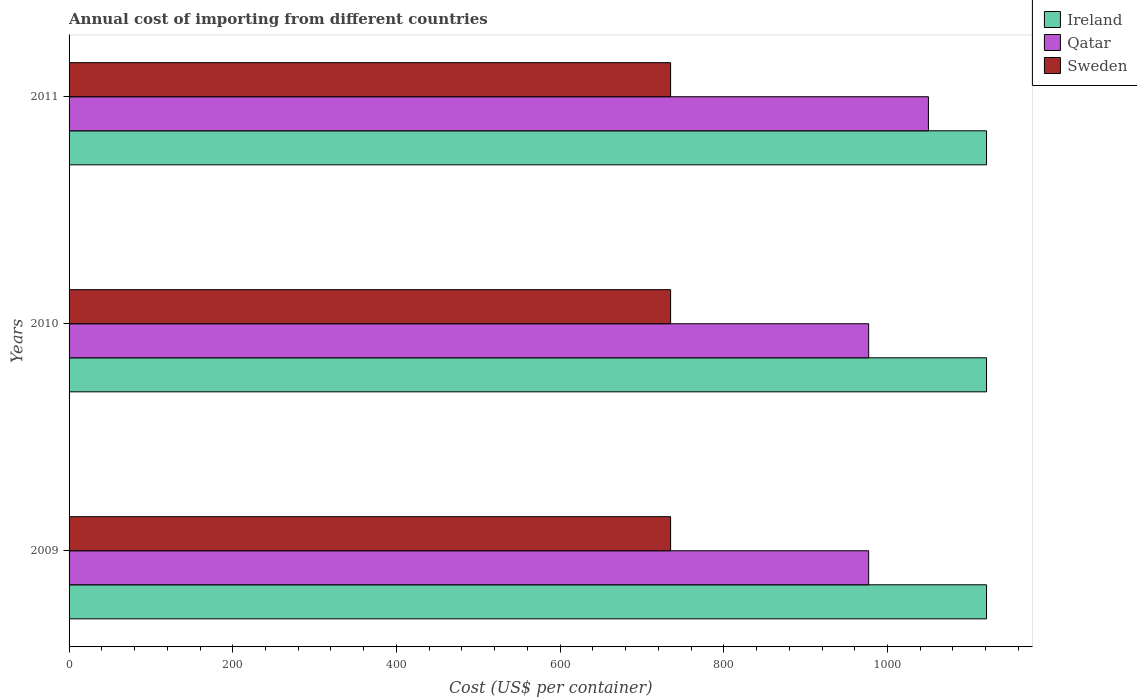What is the total annual cost of importing in Qatar in 2009?
Make the answer very short. 977. Across all years, what is the maximum total annual cost of importing in Sweden?
Make the answer very short. 735. Across all years, what is the minimum total annual cost of importing in Qatar?
Your answer should be very brief. 977. In which year was the total annual cost of importing in Sweden maximum?
Give a very brief answer. 2009. What is the total total annual cost of importing in Sweden in the graph?
Give a very brief answer. 2205. What is the difference between the total annual cost of importing in Ireland in 2009 and the total annual cost of importing in Sweden in 2011?
Keep it short and to the point. 386. What is the average total annual cost of importing in Sweden per year?
Provide a short and direct response. 735. In the year 2010, what is the difference between the total annual cost of importing in Qatar and total annual cost of importing in Ireland?
Ensure brevity in your answer.  -144. What is the ratio of the total annual cost of importing in Ireland in 2010 to that in 2011?
Make the answer very short. 1. Is the difference between the total annual cost of importing in Qatar in 2009 and 2011 greater than the difference between the total annual cost of importing in Ireland in 2009 and 2011?
Offer a very short reply. No. What is the difference between the highest and the second highest total annual cost of importing in Ireland?
Make the answer very short. 0. What is the difference between the highest and the lowest total annual cost of importing in Qatar?
Your answer should be compact. 73. In how many years, is the total annual cost of importing in Ireland greater than the average total annual cost of importing in Ireland taken over all years?
Provide a short and direct response. 0. Is the sum of the total annual cost of importing in Qatar in 2009 and 2010 greater than the maximum total annual cost of importing in Sweden across all years?
Your answer should be very brief. Yes. What does the 3rd bar from the top in 2009 represents?
Ensure brevity in your answer.  Ireland. What does the 3rd bar from the bottom in 2011 represents?
Keep it short and to the point. Sweden. Is it the case that in every year, the sum of the total annual cost of importing in Ireland and total annual cost of importing in Qatar is greater than the total annual cost of importing in Sweden?
Your answer should be very brief. Yes. How many bars are there?
Give a very brief answer. 9. Are all the bars in the graph horizontal?
Keep it short and to the point. Yes. How many years are there in the graph?
Offer a very short reply. 3. Are the values on the major ticks of X-axis written in scientific E-notation?
Give a very brief answer. No. Does the graph contain any zero values?
Provide a succinct answer. No. Where does the legend appear in the graph?
Your response must be concise. Top right. What is the title of the graph?
Give a very brief answer. Annual cost of importing from different countries. What is the label or title of the X-axis?
Give a very brief answer. Cost (US$ per container). What is the label or title of the Y-axis?
Ensure brevity in your answer.  Years. What is the Cost (US$ per container) of Ireland in 2009?
Provide a short and direct response. 1121. What is the Cost (US$ per container) in Qatar in 2009?
Make the answer very short. 977. What is the Cost (US$ per container) in Sweden in 2009?
Make the answer very short. 735. What is the Cost (US$ per container) in Ireland in 2010?
Offer a terse response. 1121. What is the Cost (US$ per container) in Qatar in 2010?
Offer a terse response. 977. What is the Cost (US$ per container) of Sweden in 2010?
Give a very brief answer. 735. What is the Cost (US$ per container) of Ireland in 2011?
Ensure brevity in your answer.  1121. What is the Cost (US$ per container) of Qatar in 2011?
Keep it short and to the point. 1050. What is the Cost (US$ per container) of Sweden in 2011?
Ensure brevity in your answer.  735. Across all years, what is the maximum Cost (US$ per container) of Ireland?
Give a very brief answer. 1121. Across all years, what is the maximum Cost (US$ per container) of Qatar?
Provide a short and direct response. 1050. Across all years, what is the maximum Cost (US$ per container) of Sweden?
Offer a terse response. 735. Across all years, what is the minimum Cost (US$ per container) of Ireland?
Offer a terse response. 1121. Across all years, what is the minimum Cost (US$ per container) in Qatar?
Your answer should be compact. 977. Across all years, what is the minimum Cost (US$ per container) of Sweden?
Your answer should be very brief. 735. What is the total Cost (US$ per container) of Ireland in the graph?
Provide a succinct answer. 3363. What is the total Cost (US$ per container) of Qatar in the graph?
Provide a short and direct response. 3004. What is the total Cost (US$ per container) in Sweden in the graph?
Offer a terse response. 2205. What is the difference between the Cost (US$ per container) in Qatar in 2009 and that in 2010?
Ensure brevity in your answer.  0. What is the difference between the Cost (US$ per container) in Qatar in 2009 and that in 2011?
Your answer should be very brief. -73. What is the difference between the Cost (US$ per container) in Sweden in 2009 and that in 2011?
Offer a terse response. 0. What is the difference between the Cost (US$ per container) in Qatar in 2010 and that in 2011?
Your response must be concise. -73. What is the difference between the Cost (US$ per container) in Sweden in 2010 and that in 2011?
Make the answer very short. 0. What is the difference between the Cost (US$ per container) in Ireland in 2009 and the Cost (US$ per container) in Qatar in 2010?
Provide a short and direct response. 144. What is the difference between the Cost (US$ per container) in Ireland in 2009 and the Cost (US$ per container) in Sweden in 2010?
Your answer should be compact. 386. What is the difference between the Cost (US$ per container) in Qatar in 2009 and the Cost (US$ per container) in Sweden in 2010?
Offer a terse response. 242. What is the difference between the Cost (US$ per container) of Ireland in 2009 and the Cost (US$ per container) of Sweden in 2011?
Your answer should be very brief. 386. What is the difference between the Cost (US$ per container) in Qatar in 2009 and the Cost (US$ per container) in Sweden in 2011?
Give a very brief answer. 242. What is the difference between the Cost (US$ per container) in Ireland in 2010 and the Cost (US$ per container) in Qatar in 2011?
Give a very brief answer. 71. What is the difference between the Cost (US$ per container) in Ireland in 2010 and the Cost (US$ per container) in Sweden in 2011?
Offer a very short reply. 386. What is the difference between the Cost (US$ per container) in Qatar in 2010 and the Cost (US$ per container) in Sweden in 2011?
Ensure brevity in your answer.  242. What is the average Cost (US$ per container) of Ireland per year?
Make the answer very short. 1121. What is the average Cost (US$ per container) in Qatar per year?
Provide a succinct answer. 1001.33. What is the average Cost (US$ per container) in Sweden per year?
Your response must be concise. 735. In the year 2009, what is the difference between the Cost (US$ per container) of Ireland and Cost (US$ per container) of Qatar?
Provide a short and direct response. 144. In the year 2009, what is the difference between the Cost (US$ per container) of Ireland and Cost (US$ per container) of Sweden?
Your response must be concise. 386. In the year 2009, what is the difference between the Cost (US$ per container) in Qatar and Cost (US$ per container) in Sweden?
Your answer should be very brief. 242. In the year 2010, what is the difference between the Cost (US$ per container) of Ireland and Cost (US$ per container) of Qatar?
Offer a terse response. 144. In the year 2010, what is the difference between the Cost (US$ per container) of Ireland and Cost (US$ per container) of Sweden?
Keep it short and to the point. 386. In the year 2010, what is the difference between the Cost (US$ per container) in Qatar and Cost (US$ per container) in Sweden?
Provide a short and direct response. 242. In the year 2011, what is the difference between the Cost (US$ per container) in Ireland and Cost (US$ per container) in Sweden?
Your answer should be compact. 386. In the year 2011, what is the difference between the Cost (US$ per container) in Qatar and Cost (US$ per container) in Sweden?
Offer a very short reply. 315. What is the ratio of the Cost (US$ per container) in Ireland in 2009 to that in 2010?
Your answer should be compact. 1. What is the ratio of the Cost (US$ per container) in Ireland in 2009 to that in 2011?
Ensure brevity in your answer.  1. What is the ratio of the Cost (US$ per container) of Qatar in 2009 to that in 2011?
Offer a very short reply. 0.93. What is the ratio of the Cost (US$ per container) of Sweden in 2009 to that in 2011?
Offer a very short reply. 1. What is the ratio of the Cost (US$ per container) in Qatar in 2010 to that in 2011?
Offer a terse response. 0.93. What is the ratio of the Cost (US$ per container) of Sweden in 2010 to that in 2011?
Your answer should be very brief. 1. What is the difference between the highest and the second highest Cost (US$ per container) in Ireland?
Your answer should be very brief. 0. What is the difference between the highest and the second highest Cost (US$ per container) in Sweden?
Offer a terse response. 0. What is the difference between the highest and the lowest Cost (US$ per container) in Ireland?
Provide a short and direct response. 0. 